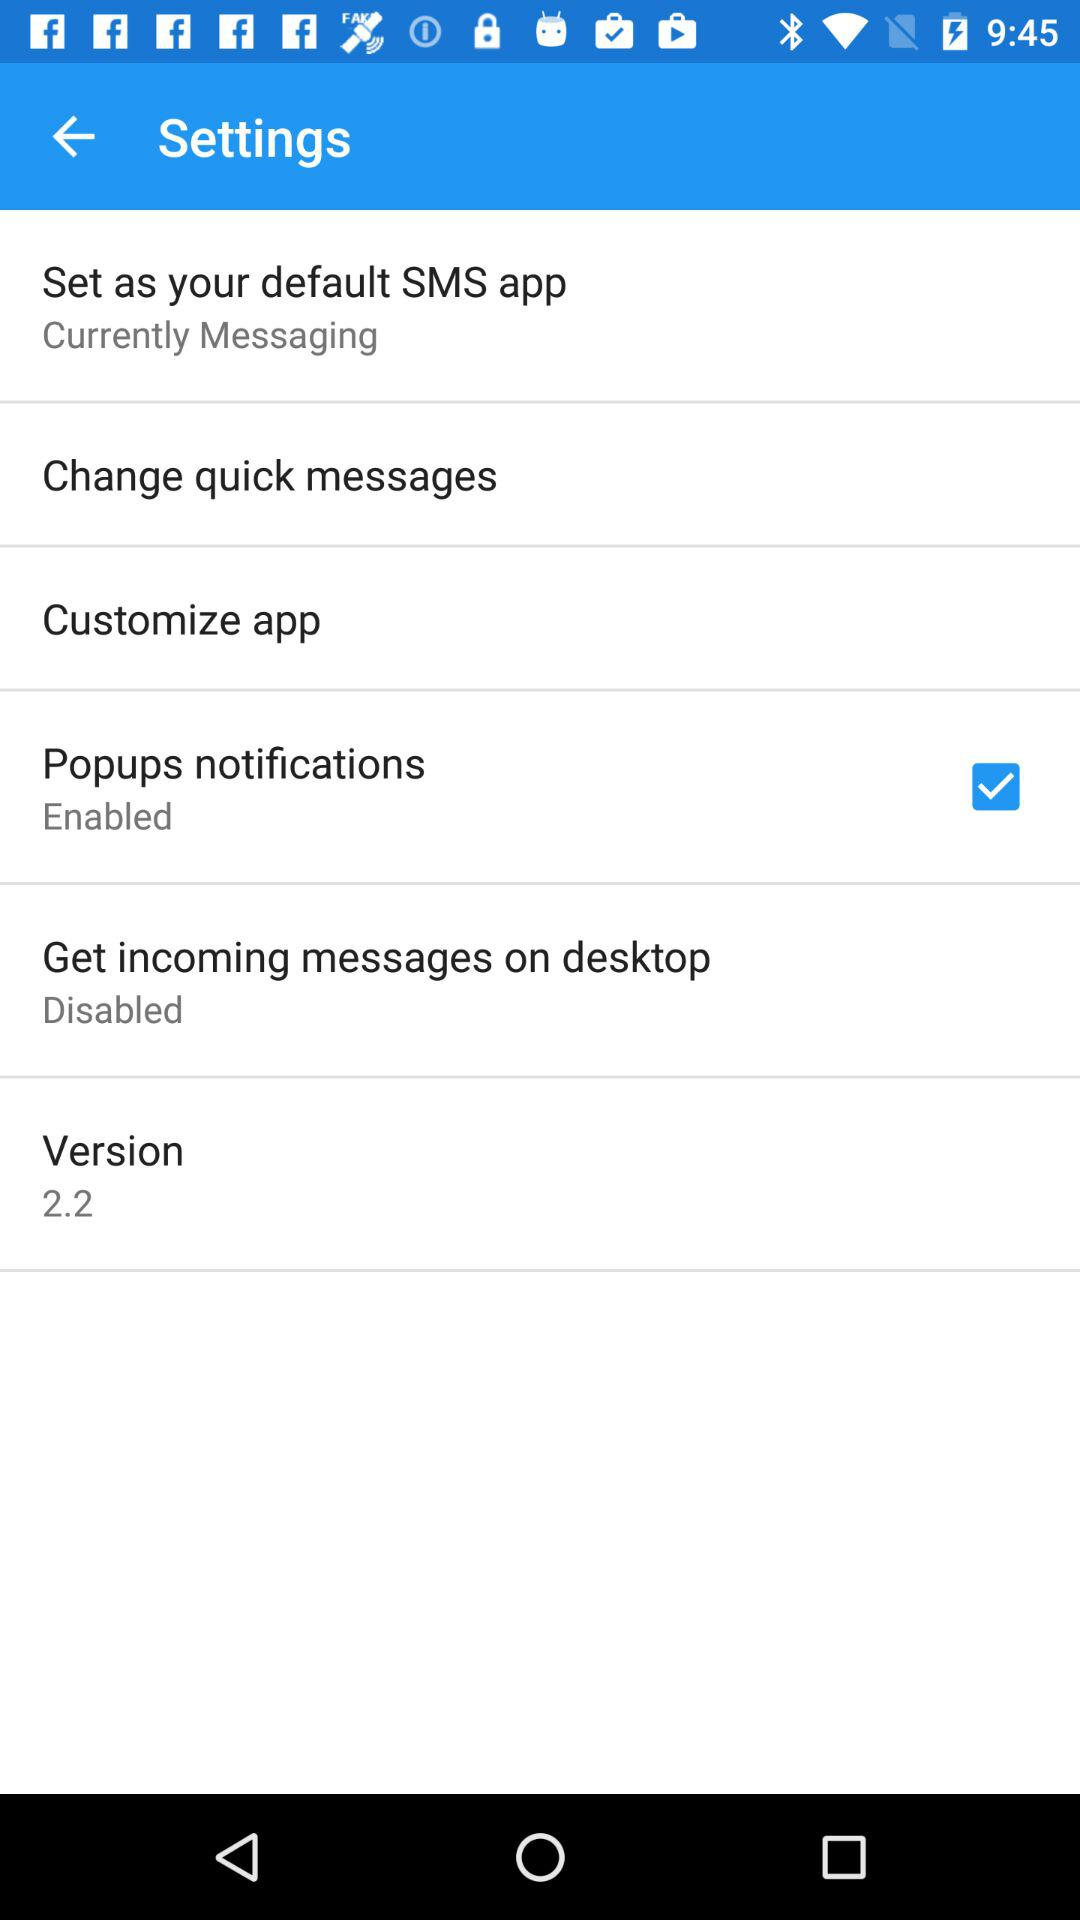Which version of the application is this? The version of the application is 2.2. 